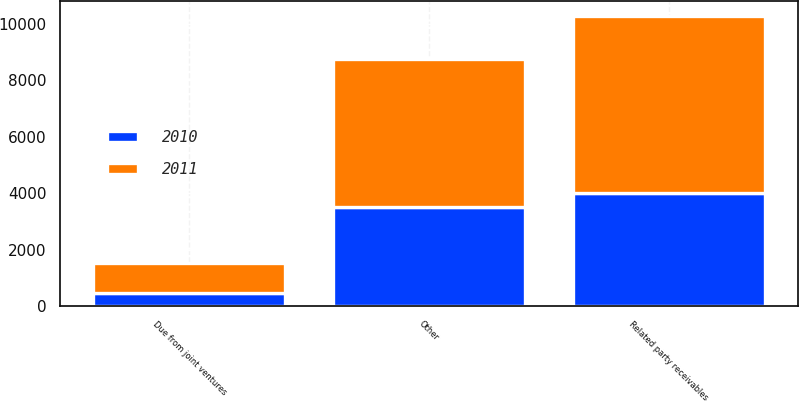<chart> <loc_0><loc_0><loc_500><loc_500><stacked_bar_chart><ecel><fcel>Due from joint ventures<fcel>Other<fcel>Related party receivables<nl><fcel>2010<fcel>477<fcel>3524<fcel>4001<nl><fcel>2011<fcel>1062<fcel>5233<fcel>6295<nl></chart> 